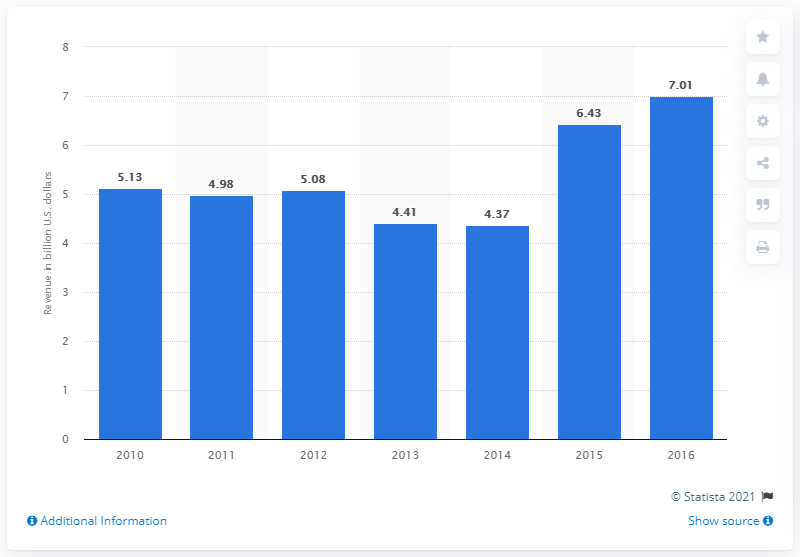Draw attention to some important aspects in this diagram. The revenue of professional and scholarly book publishing in the United States in 2016 was $7.01 billion. 